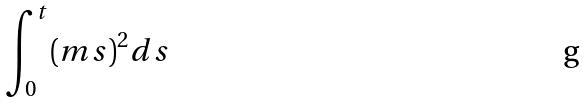<formula> <loc_0><loc_0><loc_500><loc_500>\int _ { 0 } ^ { t } ( m s ) ^ { 2 } d s</formula> 